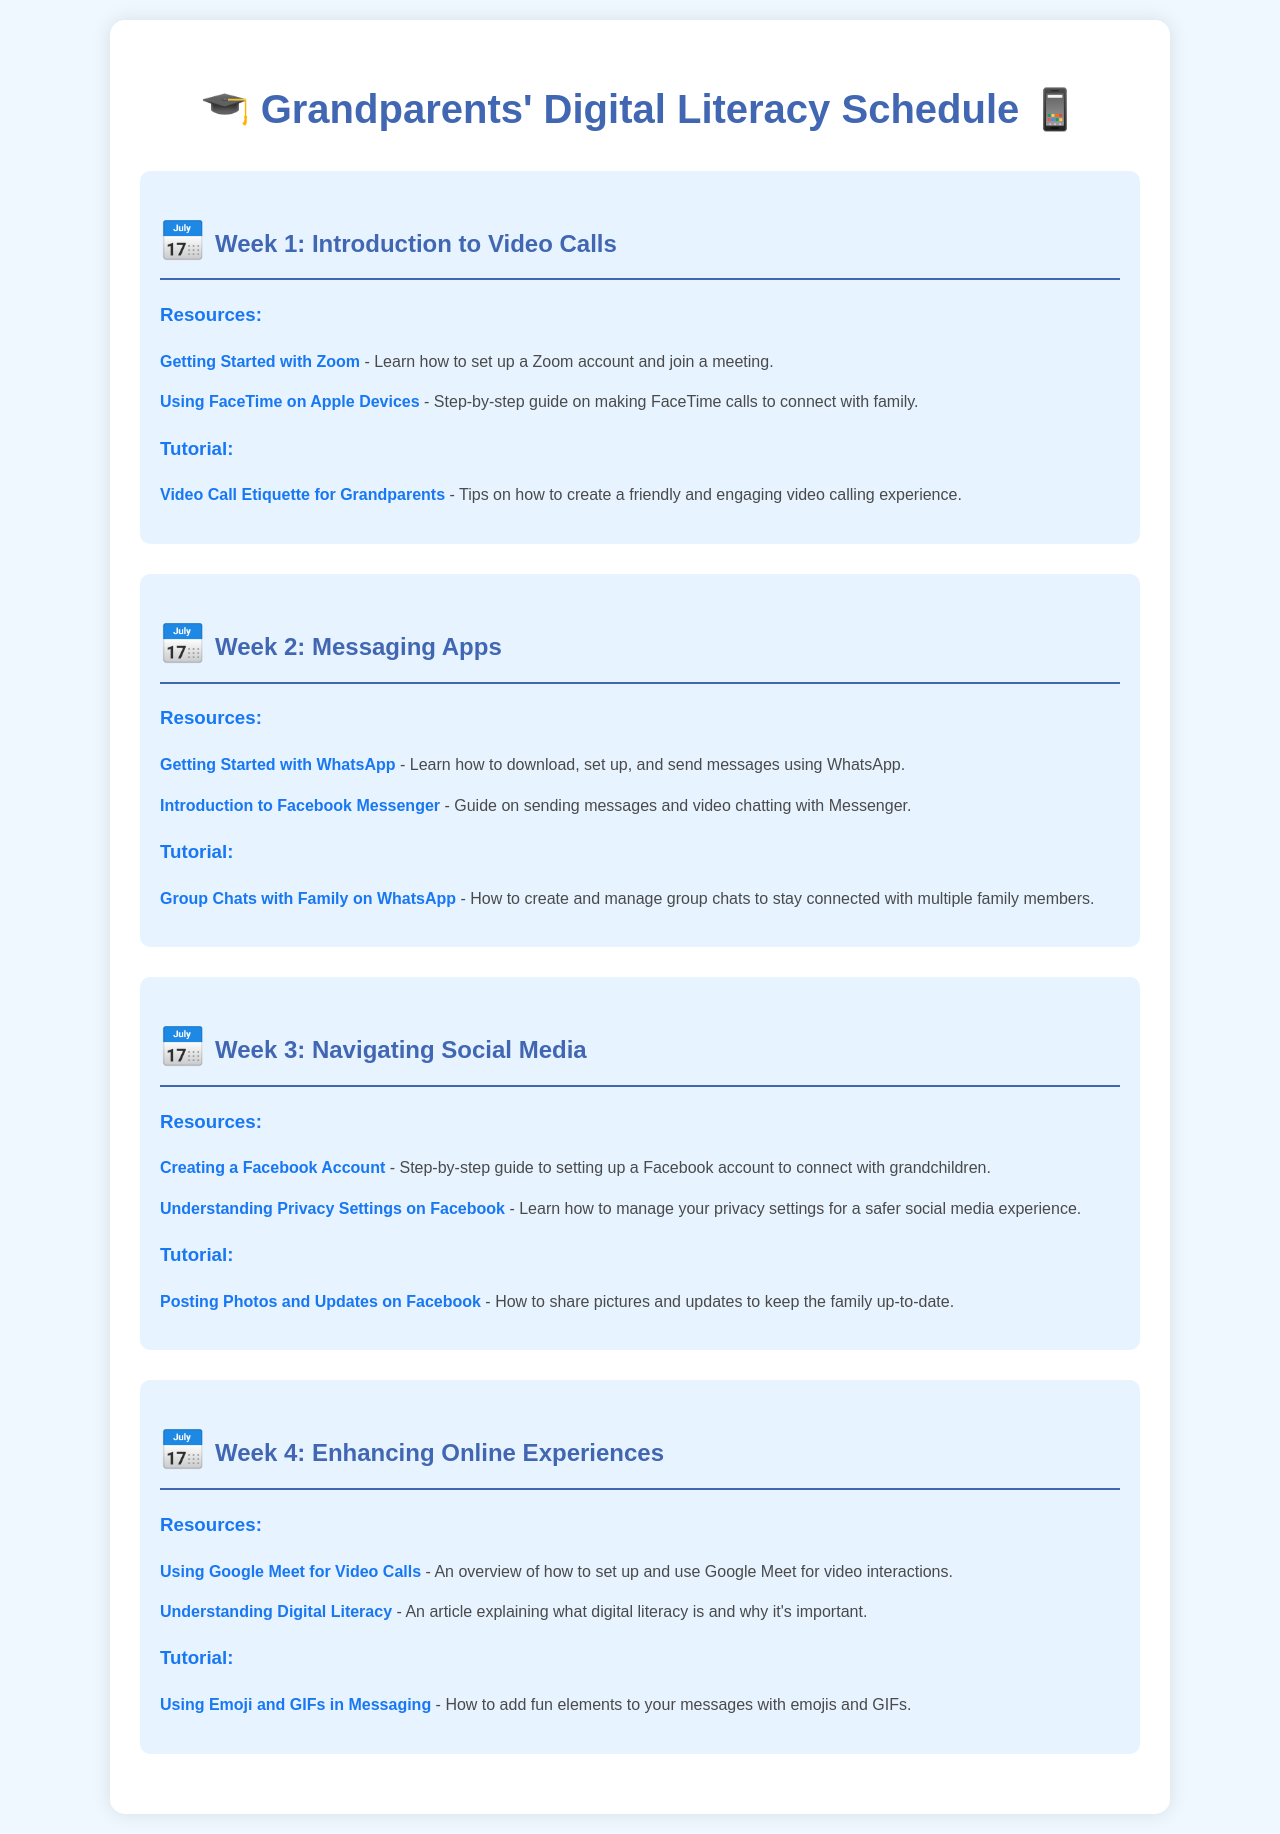What is the title of the schedule? The title at the top of the document states "Grandparents' Digital Literacy Schedule."
Answer: Grandparents' Digital Literacy Schedule How many weeks does the schedule cover? The document discusses activities and topics for four separate weeks.
Answer: 4 What is the first topic in Week 1? The first topic outlined for Week 1 is "Introduction to Video Calls."
Answer: Introduction to Video Calls Which app is introduced in Week 2 for messaging? Week 2 introduces "WhatsApp" as a messaging app.
Answer: WhatsApp What type of content is included in each week? Each week includes resources and a tutorial, providing a structured learning experience.
Answer: Resources and tutorial How many resources are listed in Week 3? Week 3 lists two resources related to navigating social media.
Answer: 2 What is one of the tutorials offered in Week 4? The tutorial offered in Week 4 is about "Using Emoji and GIFs in Messaging."
Answer: Using Emoji and GIFs in Messaging Which service is featured for video calls in Week 4? The video calling service featured in Week 4 is "Google Meet."
Answer: Google Meet What color is the background of the document? The background color of the document is a light blue shade (#f0f8ff).
Answer: Light blue 